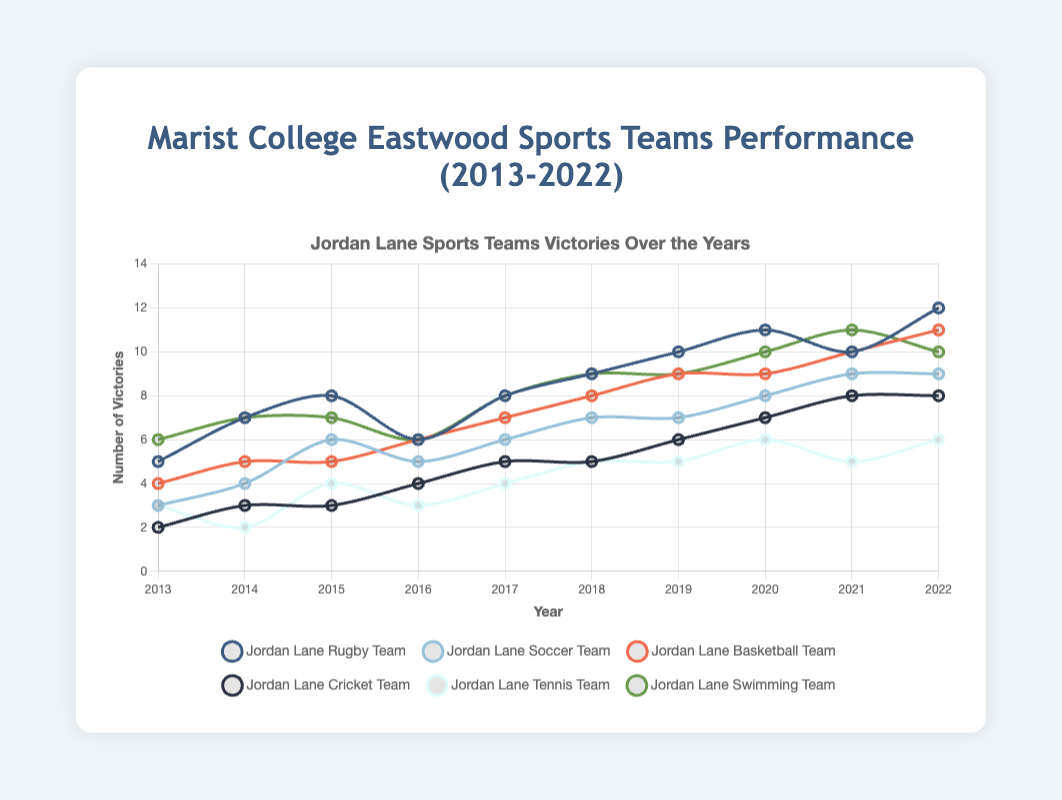What team had the highest number of victories in 2022? Look at the data for 2022 and compare the number of victories for each team. The Jordan Lane Rugby Team had the highest number of victories with 12 wins.
Answer: Jordan Lane Rugby Team Compare the performance of the Jordan Lane Basketball Team and the Jordan Lane Soccer Team in 2020. Which team had more victories? Check the 2020 data for both teams. The Jordan Lane Basketball Team and the Jordan Lane Soccer Team both had 9 victories.
Answer: Both teams had the same number of victories Which team showed the largest improvement over the decade? Calculate the difference between 2013 and 2022 victories for each team. The Jordan Lane Cricket Team showed the largest increase, improving by 6 victories (from 2 to 8).
Answer: Jordan Lane Cricket Team In which year did the Jordan Lane Tennis Team experience a decrease in victories compared to the previous year? Track the data points for the Jordan Lane Tennis Team. The victories decreased from 3 in 2013 to 2 in 2014, which is the only instance of a decrease.
Answer: 2014 What is the average number of victories of the Jordan Lane Swimming Team over the decade? Sum all the victories of the Jordan Lane Swimming Team from 2013 to 2022 and divide by the number of years (10). (6+7+7+6+8+9+9+10+11+10) = 83, 83/10 = 8.3
Answer: 8.3 Between which consecutive years did the Jordan Lane Rugby Team see the largest increase in victories? Look at the differences between consecutive years. The largest increase was from 2020 to 2021, where victories increased from 11 to 12.
Answer: 2020 to 2021 Which team had the least total number of victories over the decade? Sum the victories for each team and compare. The Jordan Lane Tennis Team had the least total victories, summing to 39.
Answer: Jordan Lane Tennis Team Which two teams had the same number of victories in any year? Compare the yearly data for all teams. In 2017, the Jordan Lane Swimming Team and the Jordan Lane Rugby Team both had 8 victories.
Answer: Jordan Lane Swimming Team and Jordan Lane Rugby Team What is the difference in the number of victories between the highest and lowest performing teams in 2016? Look at the victories for each team in 2016. The Jordan Lane Rugby Team had 6 victories, and the Jordan Lane Cricket Team had 4 victories. The difference is 6 - 4 = 2.
Answer: 2 